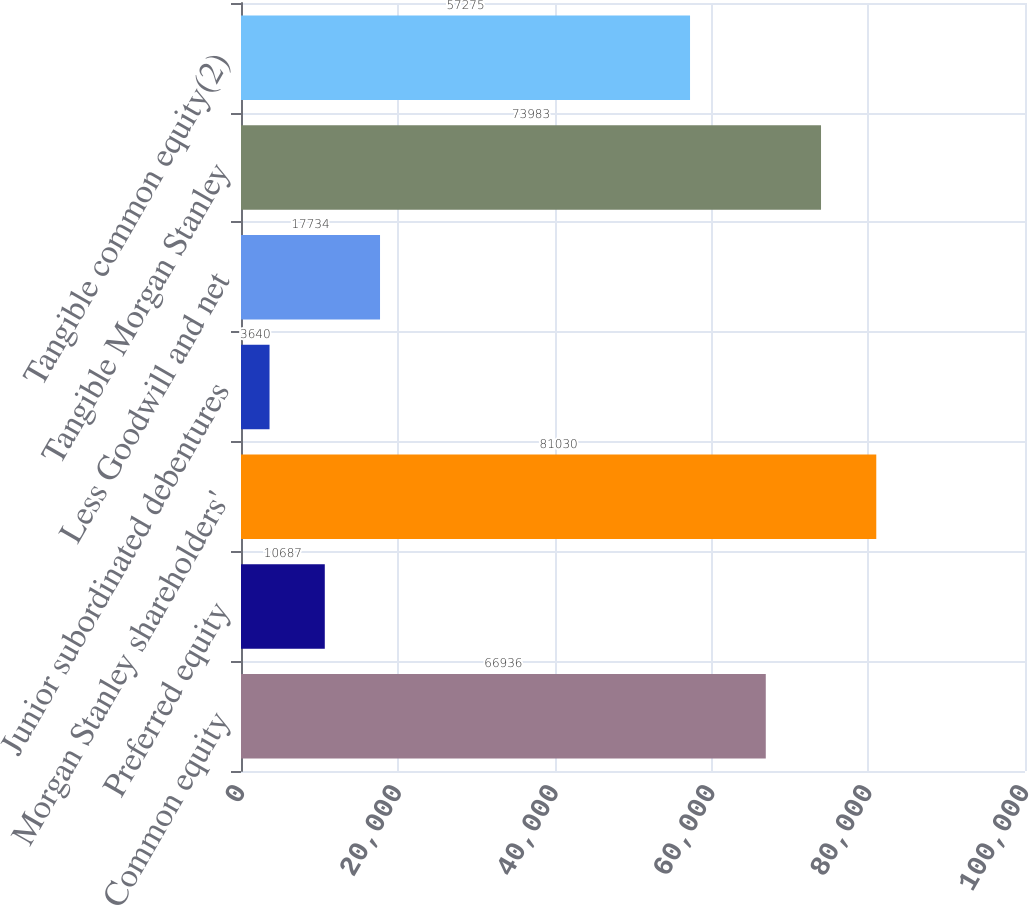<chart> <loc_0><loc_0><loc_500><loc_500><bar_chart><fcel>Common equity<fcel>Preferred equity<fcel>Morgan Stanley shareholders'<fcel>Junior subordinated debentures<fcel>Less Goodwill and net<fcel>Tangible Morgan Stanley<fcel>Tangible common equity(2)<nl><fcel>66936<fcel>10687<fcel>81030<fcel>3640<fcel>17734<fcel>73983<fcel>57275<nl></chart> 